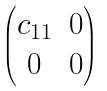<formula> <loc_0><loc_0><loc_500><loc_500>\begin{pmatrix} c _ { 1 1 } & 0 \\ 0 & 0 \end{pmatrix}</formula> 